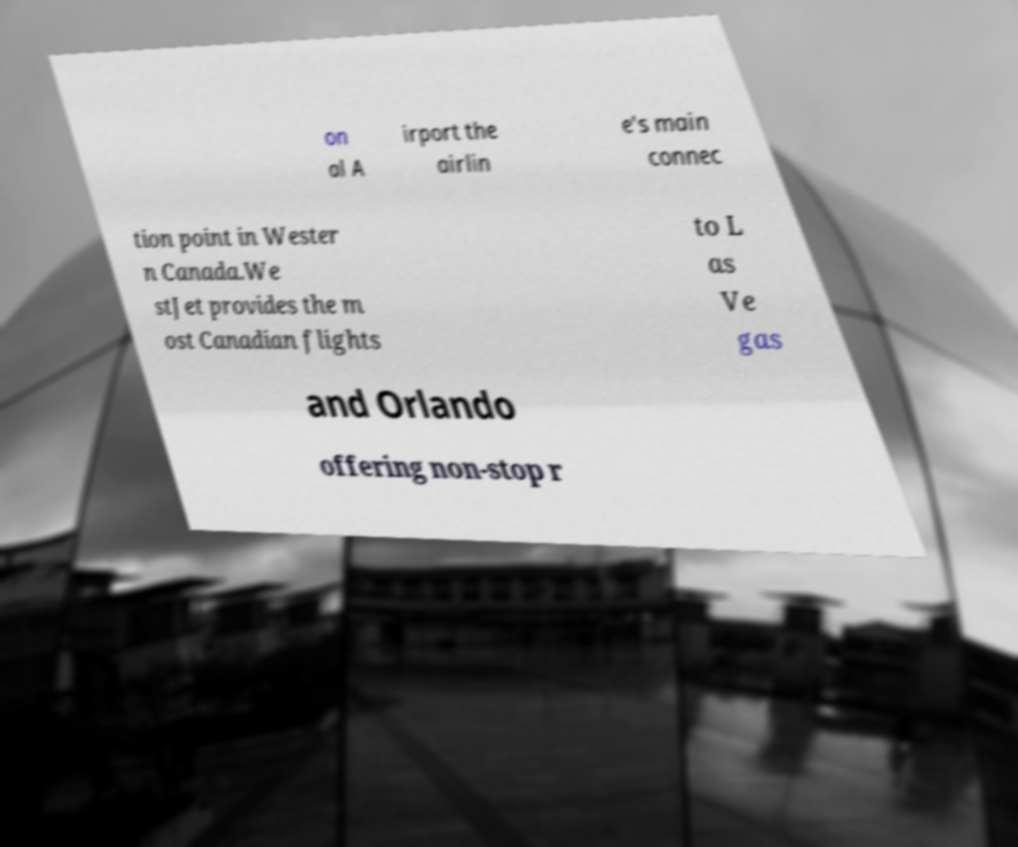Can you read and provide the text displayed in the image?This photo seems to have some interesting text. Can you extract and type it out for me? on al A irport the airlin e's main connec tion point in Wester n Canada.We stJet provides the m ost Canadian flights to L as Ve gas and Orlando offering non-stop r 